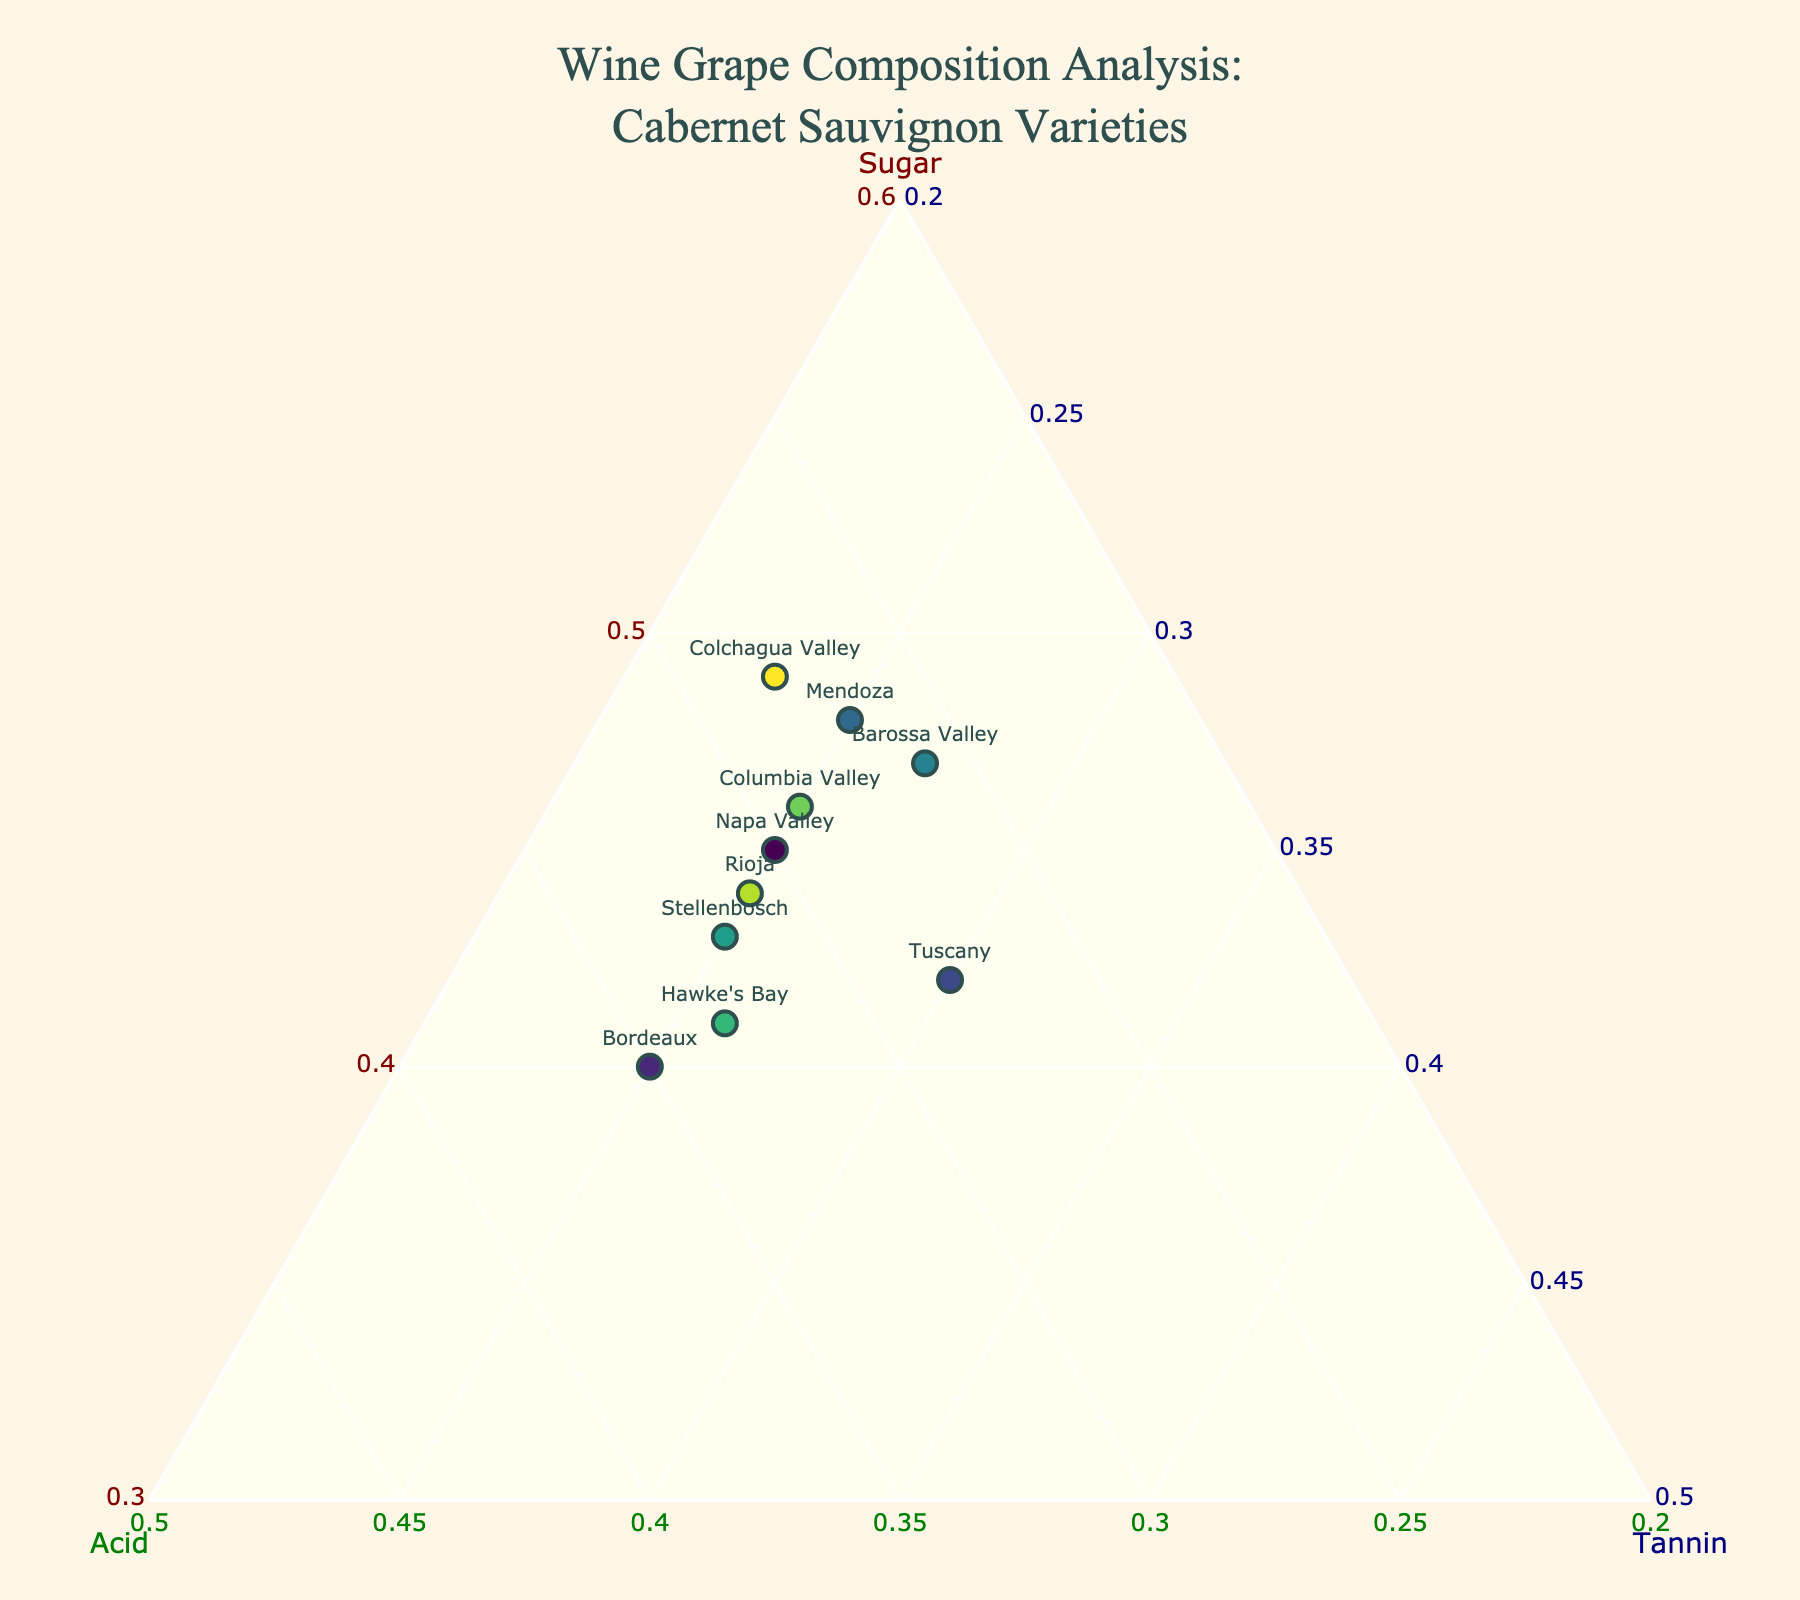What is the title of the figure? The title is usually found at the top of the figure and summarizes what the plot is about. In this case, the title given is "Wine Grape Composition Analysis: Cabernet Sauvignon Varieties".
Answer: Wine Grape Composition Analysis: Cabernet Sauvignon Varieties Which region has the highest sugar content? To find the region with the highest sugar content, look for the point on the plot with the highest value along the axis labeled 'Sugar'.
Answer: Colchagua Valley (49) What range of acid levels are present among the different regions? To determine the range of acid levels, identify the minimum and maximum values on the 'Acid' axis based on the points in the plot. The minimum acid level is Mendoza (27), and the maximum acid level is Bordeaux (35).
Answer: 27 to 35 Which region has an equal amount of sugar and tannin? Examine the points on the plot and check the textual labels to find the region where the values of sugar and tannin are the same. This means looking for a set of coordinates where a = c. There is no region where sugar and tannin are exactly equal, but Colchagua Valley has values that are close, with 49 for sugar and 23 for tannin.
Answer: None How do the sugar levels in Bordeaux and Napa Valley compare? Locate the points for Bordeaux and Napa Valley and compare their 'Sugar' coordinates. Bordeaux has a sugar level of 40 and Napa Valley has a sugar level of 45.
Answer: Napa Valley has higher sugar than Bordeaux What is the average sugar content across all regions? To find the average sugar content, sum all the sugar values and divide by the number of data points. (45 + 40 + 42 + 48 + 47 + 43 + 41 + 46 + 44 + 49) / 10 = 445 / 10.
Answer: 44.5 Which region has the lowest tannin content? Look for the point on the plot with the lowest value along the axis labeled 'Tannin'.
Answer: Colchagua Valley (23) Is there any region where the acid level is higher than both the sugar and tannin levels? Examine each point and its corresponding three values to see if the 'Acid' value is higher than both 'Sugar' and 'Tannin' values for any region. No region matches this criterion as the highest acid level (35 in Bordeaux) is still lower than respective sugar levels.
Answer: No How does the compositional balance of Tuscany compare to Barossa Valley? Compare the 'Sugar', 'Acid', and 'Tannin' levels of Tuscany and Barossa Valley by reading the coordinates for each region. Tuscany has sugar=42, acid=28, tannin=30, while Barossa Valley has sugar=47, acid=26, tannin=27. Barossa Valley has higher sugar, lower acid, and lower tannin compared to Tuscany.
Answer: Tuscany has lower sugar, higher acid, and higher tannin than Barossa Valley What color represents the Columbia Valley on the plot? Color coding often helps differentiate data points. Locate the Columbia Valley on the plot and identify its color based on the given colorscale, Viridis.
Answer: A shade within the Viridis colorscale 